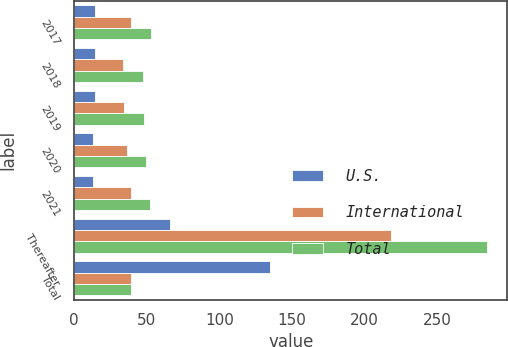<chart> <loc_0><loc_0><loc_500><loc_500><stacked_bar_chart><ecel><fcel>2017<fcel>2018<fcel>2019<fcel>2020<fcel>2021<fcel>Thereafter<fcel>Total<nl><fcel>U.S.<fcel>14.2<fcel>14.2<fcel>14.1<fcel>13.2<fcel>13.1<fcel>66.1<fcel>134.9<nl><fcel>International<fcel>38.9<fcel>33.4<fcel>34.2<fcel>36.3<fcel>39.1<fcel>218<fcel>39.1<nl><fcel>Total<fcel>53.1<fcel>47.6<fcel>48.3<fcel>49.5<fcel>52.2<fcel>284.1<fcel>39.1<nl></chart> 